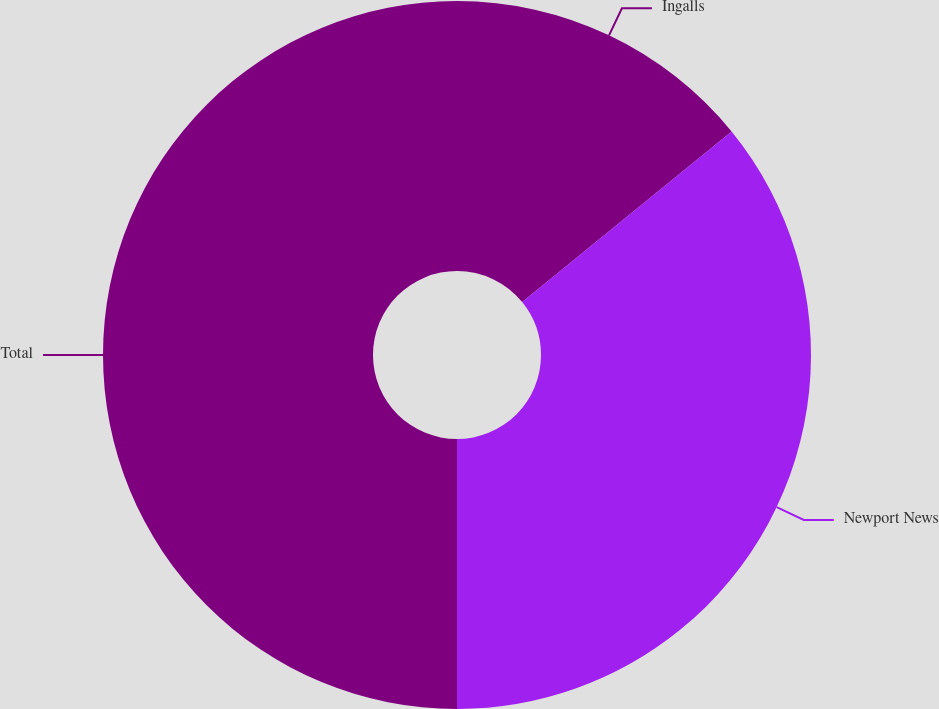Convert chart. <chart><loc_0><loc_0><loc_500><loc_500><pie_chart><fcel>Ingalls<fcel>Newport News<fcel>Total<nl><fcel>14.13%<fcel>35.87%<fcel>50.0%<nl></chart> 